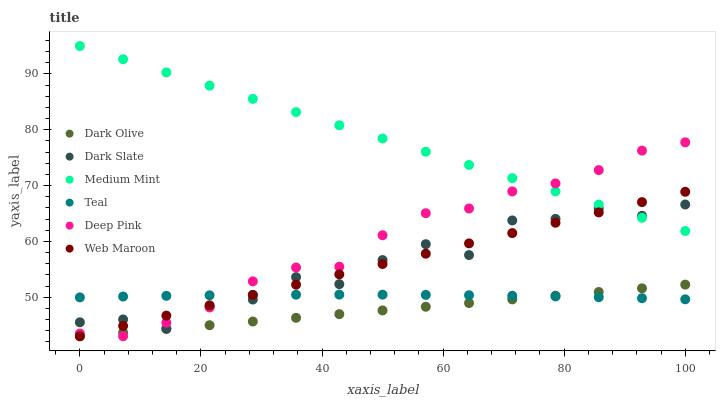Does Dark Olive have the minimum area under the curve?
Answer yes or no. Yes. Does Medium Mint have the maximum area under the curve?
Answer yes or no. Yes. Does Deep Pink have the minimum area under the curve?
Answer yes or no. No. Does Deep Pink have the maximum area under the curve?
Answer yes or no. No. Is Dark Olive the smoothest?
Answer yes or no. Yes. Is Dark Slate the roughest?
Answer yes or no. Yes. Is Deep Pink the smoothest?
Answer yes or no. No. Is Deep Pink the roughest?
Answer yes or no. No. Does Deep Pink have the lowest value?
Answer yes or no. Yes. Does Dark Slate have the lowest value?
Answer yes or no. No. Does Medium Mint have the highest value?
Answer yes or no. Yes. Does Deep Pink have the highest value?
Answer yes or no. No. Is Dark Olive less than Dark Slate?
Answer yes or no. Yes. Is Medium Mint greater than Dark Olive?
Answer yes or no. Yes. Does Deep Pink intersect Web Maroon?
Answer yes or no. Yes. Is Deep Pink less than Web Maroon?
Answer yes or no. No. Is Deep Pink greater than Web Maroon?
Answer yes or no. No. Does Dark Olive intersect Dark Slate?
Answer yes or no. No. 